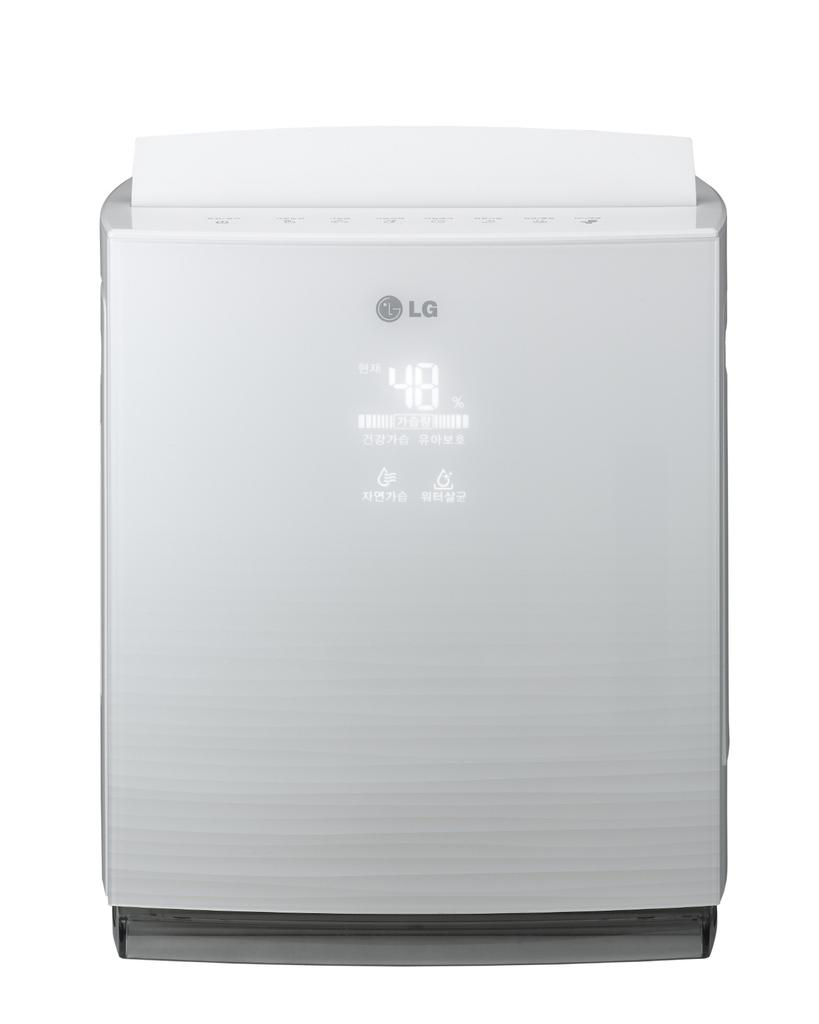<image>
Write a terse but informative summary of the picture. A large office type LG 48% copier is on display here. 